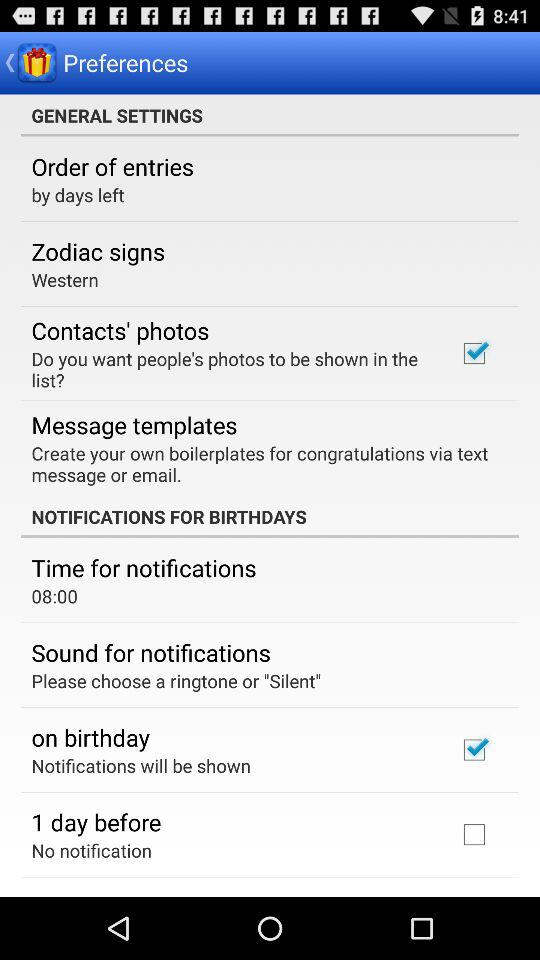What is the status of "1 day before"? The status of "1 day before" is "off". 